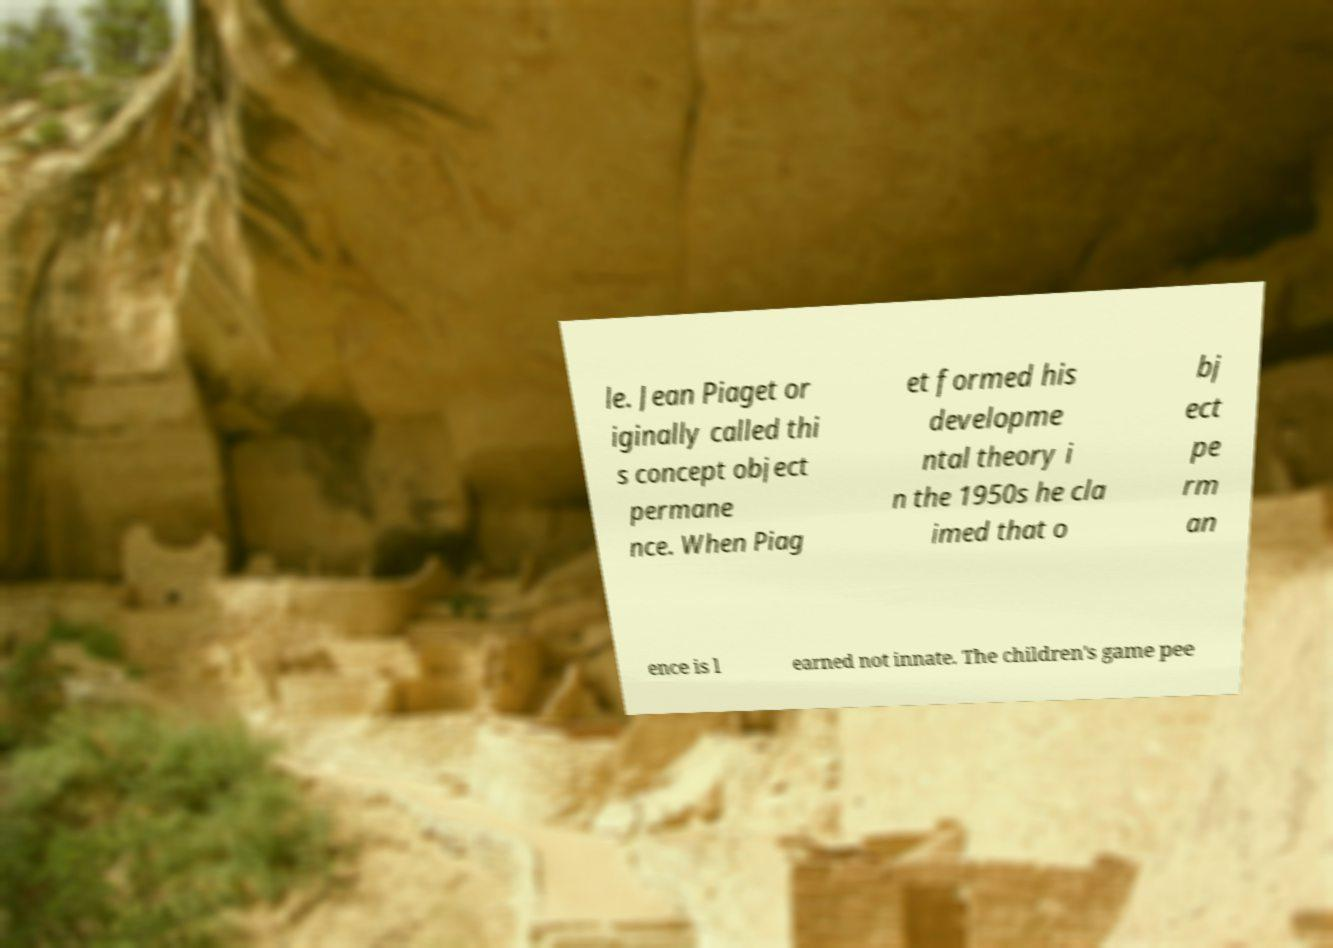There's text embedded in this image that I need extracted. Can you transcribe it verbatim? le. Jean Piaget or iginally called thi s concept object permane nce. When Piag et formed his developme ntal theory i n the 1950s he cla imed that o bj ect pe rm an ence is l earned not innate. The children's game pee 